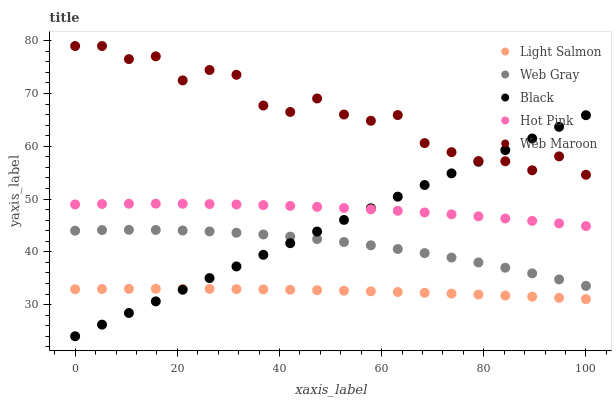Does Light Salmon have the minimum area under the curve?
Answer yes or no. Yes. Does Web Maroon have the maximum area under the curve?
Answer yes or no. Yes. Does Web Gray have the minimum area under the curve?
Answer yes or no. No. Does Web Gray have the maximum area under the curve?
Answer yes or no. No. Is Black the smoothest?
Answer yes or no. Yes. Is Web Maroon the roughest?
Answer yes or no. Yes. Is Light Salmon the smoothest?
Answer yes or no. No. Is Light Salmon the roughest?
Answer yes or no. No. Does Black have the lowest value?
Answer yes or no. Yes. Does Light Salmon have the lowest value?
Answer yes or no. No. Does Web Maroon have the highest value?
Answer yes or no. Yes. Does Web Gray have the highest value?
Answer yes or no. No. Is Web Gray less than Web Maroon?
Answer yes or no. Yes. Is Web Maroon greater than Web Gray?
Answer yes or no. Yes. Does Web Gray intersect Black?
Answer yes or no. Yes. Is Web Gray less than Black?
Answer yes or no. No. Is Web Gray greater than Black?
Answer yes or no. No. Does Web Gray intersect Web Maroon?
Answer yes or no. No. 